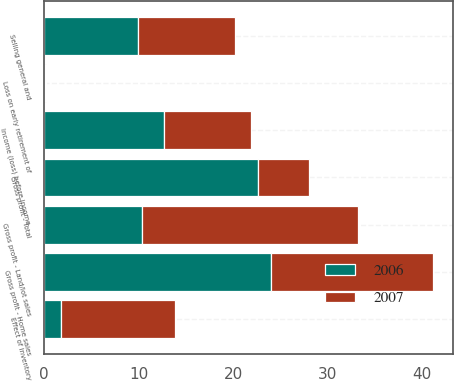Convert chart to OTSL. <chart><loc_0><loc_0><loc_500><loc_500><stacked_bar_chart><ecel><fcel>Gross profit - Home sales<fcel>Gross profit - Land/lot sales<fcel>Effect of inventory<fcel>Gross profit - Total<fcel>Selling general and<fcel>Loss on early retirement of<fcel>Income (loss) before income<nl><fcel>2007<fcel>17.2<fcel>22.9<fcel>12<fcel>5.4<fcel>10.3<fcel>0.1<fcel>9.2<nl><fcel>2006<fcel>24<fcel>10.3<fcel>1.8<fcel>22.6<fcel>9.9<fcel>0.1<fcel>12.7<nl></chart> 